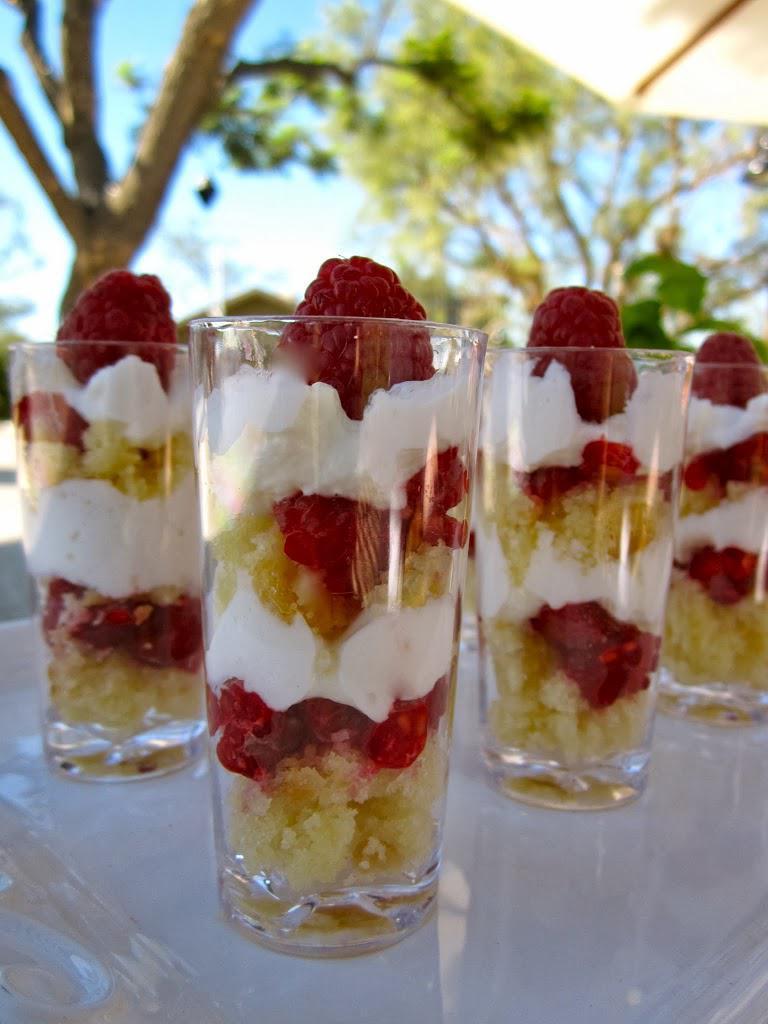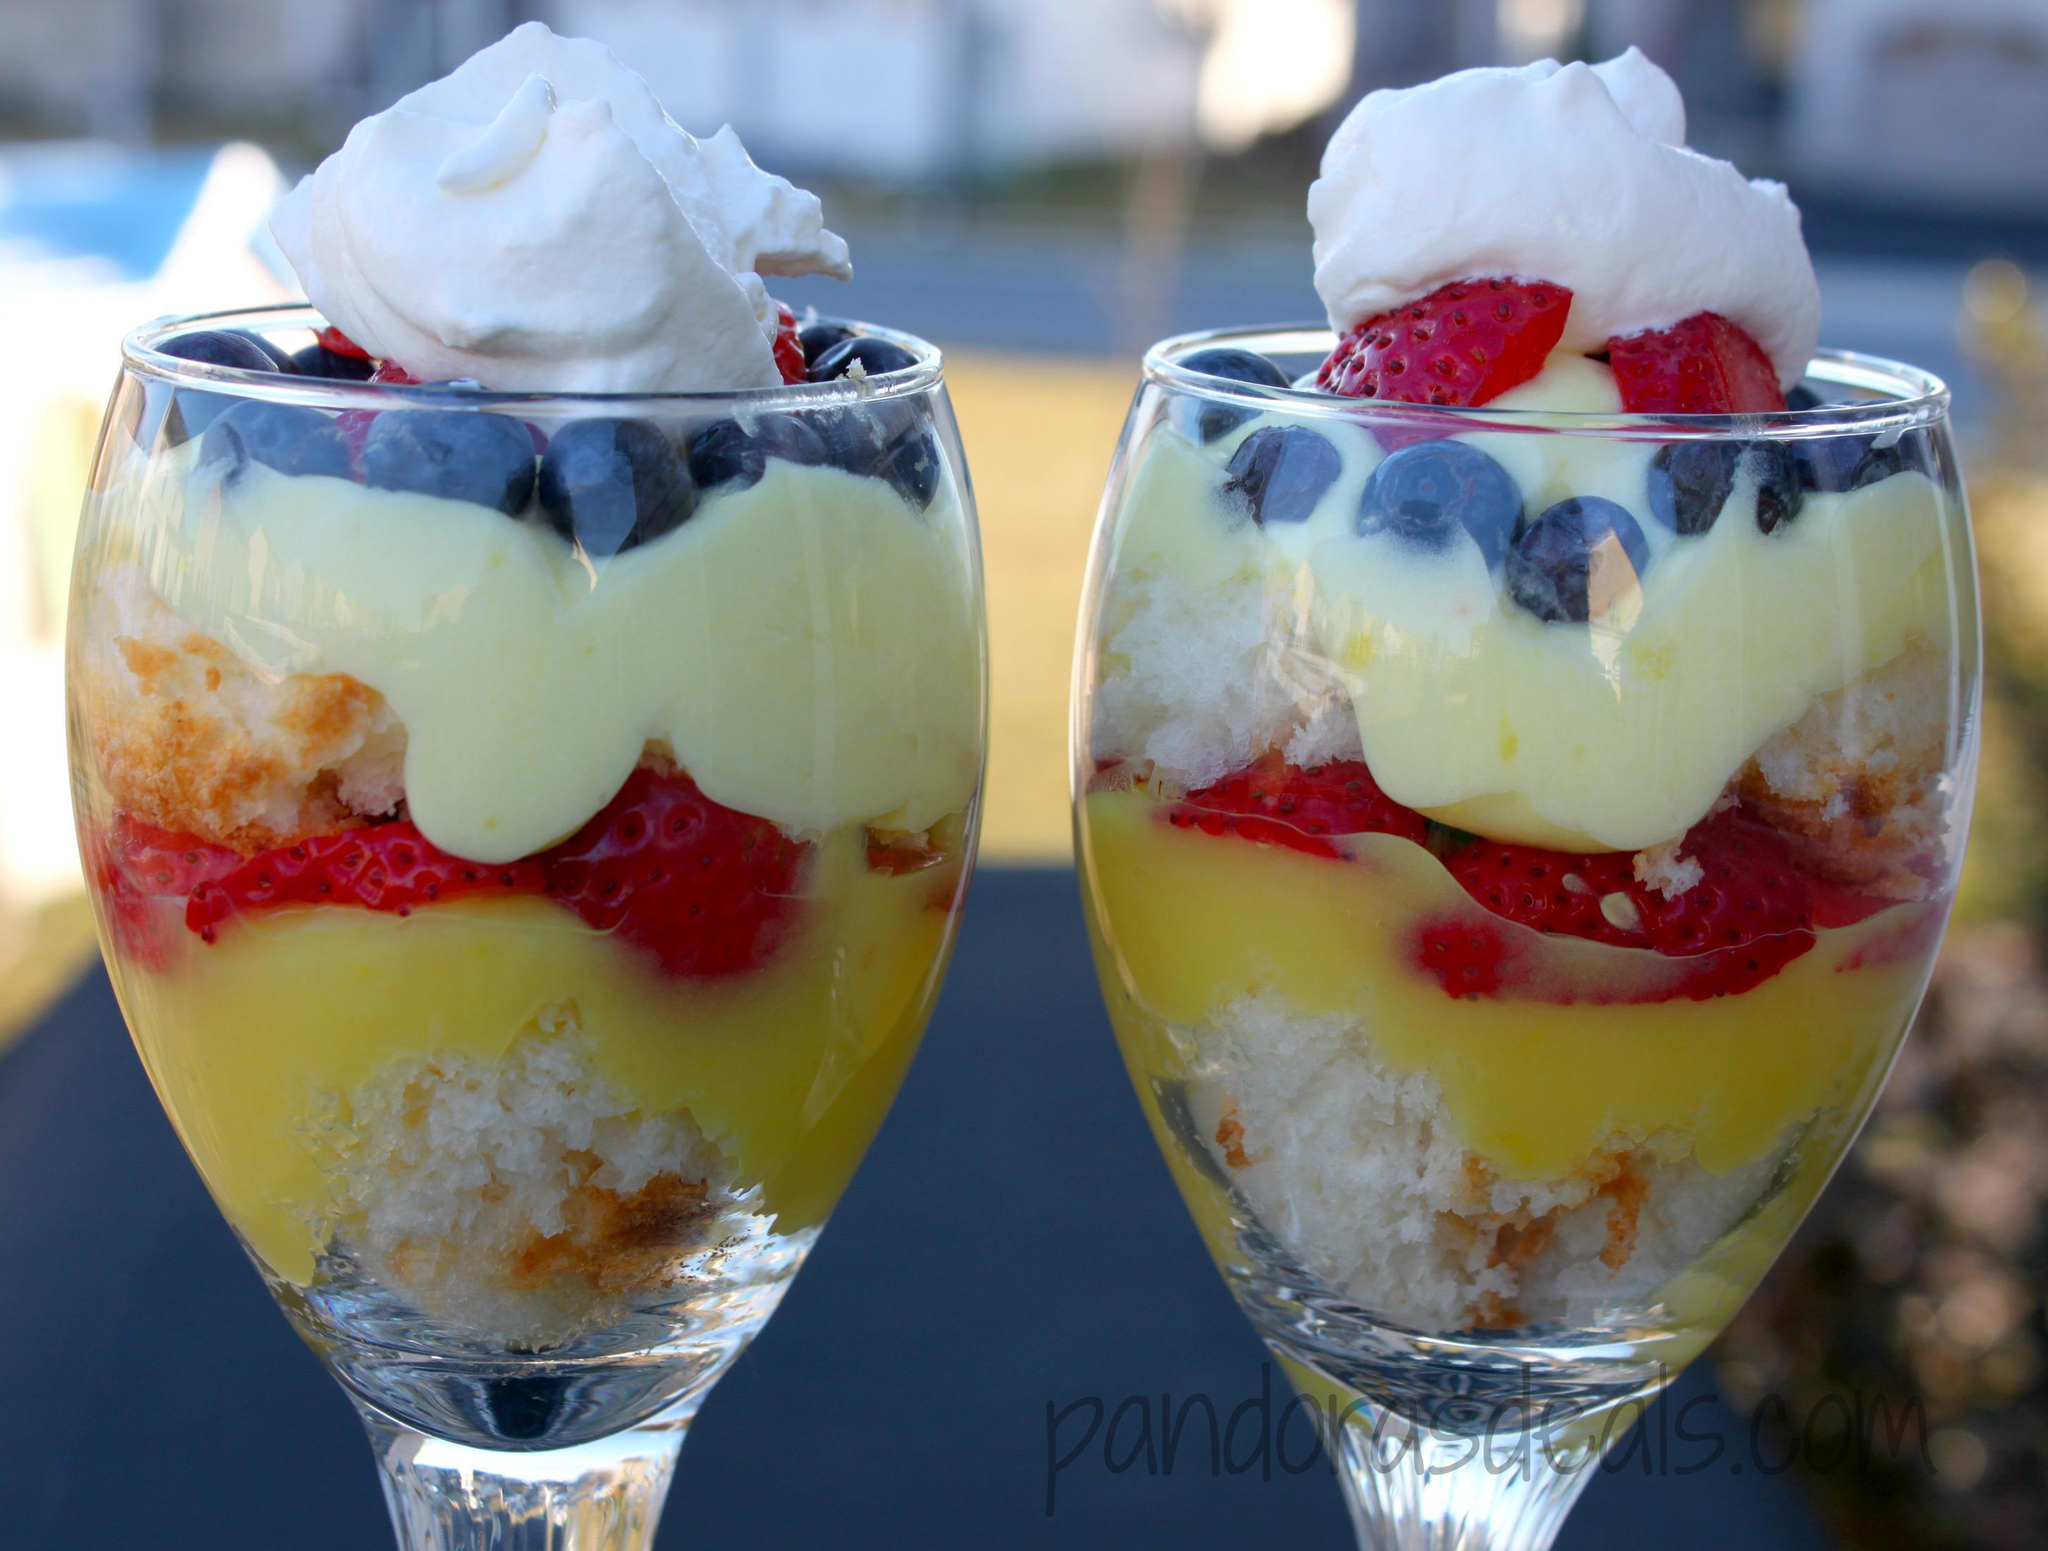The first image is the image on the left, the second image is the image on the right. Analyze the images presented: Is the assertion "An image shows side-by-side desserts with blueberries around the rim." valid? Answer yes or no. Yes. The first image is the image on the left, the second image is the image on the right. Assess this claim about the two images: "In one image, two individual desserts have layers of strawberries and blueberries, and are topped with whipped cream.". Correct or not? Answer yes or no. Yes. 